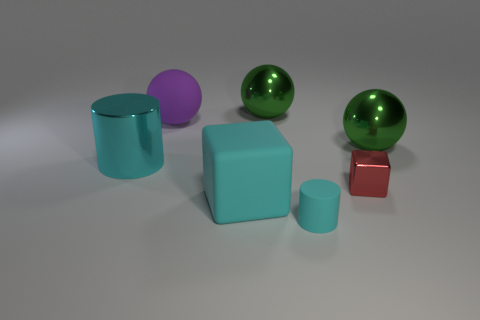Subtract all brown cubes. How many green balls are left? 2 Add 1 red metallic things. How many objects exist? 8 Subtract all metal balls. How many balls are left? 1 Add 7 cyan matte cylinders. How many cyan matte cylinders exist? 8 Subtract 0 gray blocks. How many objects are left? 7 Subtract all cubes. How many objects are left? 5 Subtract all big rubber objects. Subtract all yellow matte things. How many objects are left? 5 Add 4 balls. How many balls are left? 7 